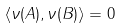<formula> <loc_0><loc_0><loc_500><loc_500>\langle \nu ( A ) , \nu ( B ) \rangle = 0</formula> 